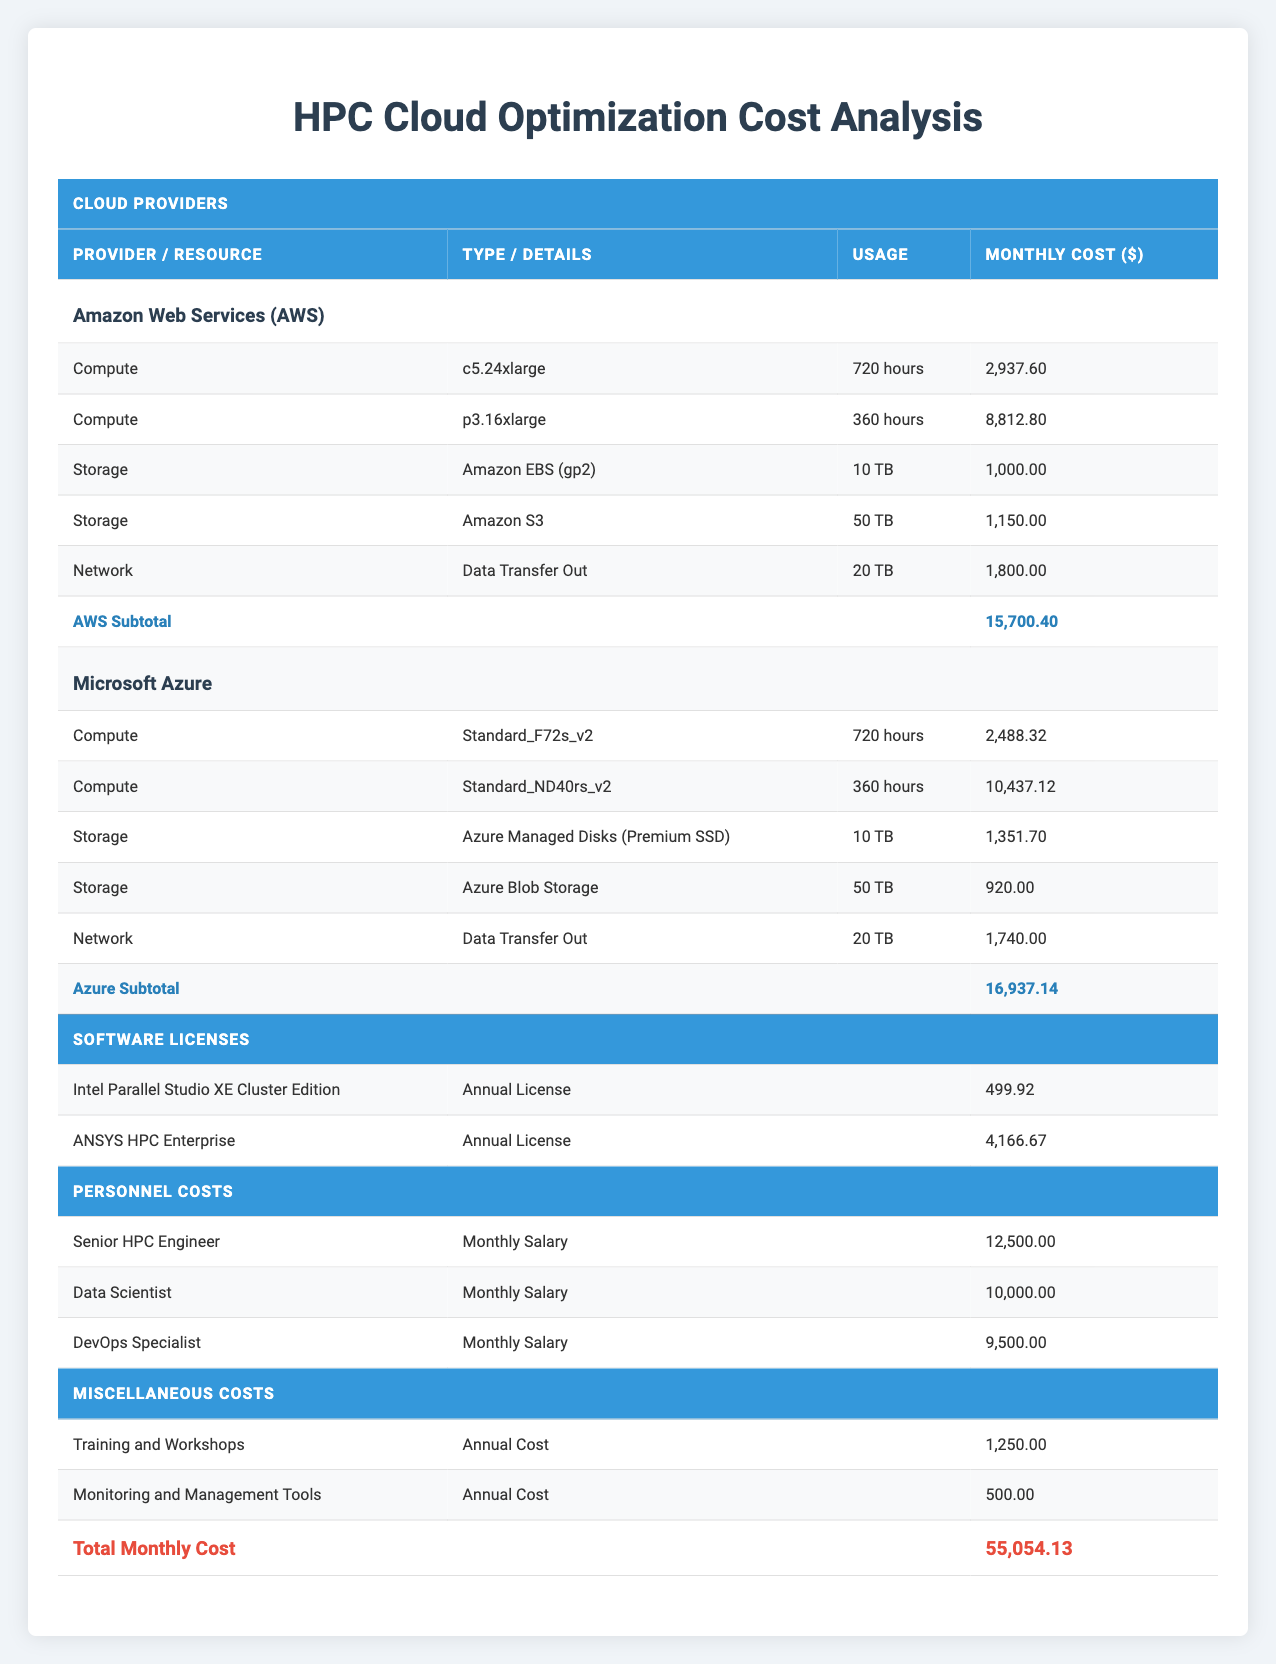What is the total monthly cost for using Amazon Web Services (AWS)? To find the total monthly cost for AWS, we need to sum up the monthly costs of its compute, storage, and network resources. The compute costs are 2,937.60 + 8,812.80 = 11,750.40. The storage costs are 1,000.00 + 1,150.00 = 2,150.00. The network cost is 1,800.00. Adding these together yields: 11,750.40 + 2,150.00 + 1,800.00 = 15,700.40.
Answer: 15,700.40 What is the monthly cost of the Standard_ND40rs_v2 instance on Microsoft Azure? The monthly cost for the Standard_ND40rs_v2 instance is clearly stated in the Azure section of the table as 10,437.12.
Answer: 10,437.12 Are the monthly costs of AWS storage resources higher than those of Microsoft Azure? The total monthly costs of AWS storage are 1,000.00 (EBS) + 1,150.00 (S3) = 2,150.00. The total monthly costs of Azure storage are 1,351.70 (Managed Disks) + 920.00 (Blob Storage) = 2,271.70. Comparing both totals shows that 2,150.00 (AWS) is not greater than 2,271.70 (Azure), therefore the statement is false.
Answer: No What is the difference in total monthly personnel costs between the Senior HPC Engineer and the Data Scientist? The monthly salary of the Senior HPC Engineer is 12,500.00, and the monthly salary of the Data Scientist is 10,000.00. To find the difference, we subtract the Data Scientist's salary from that of the Senior HPC Engineer: 12,500.00 - 10,000.00 = 2,500.00.
Answer: 2,500.00 Which cloud provider has the highest total monthly cost? First, we need to calculate the total costs for both AWS and Azure. For AWS, as calculated earlier, the total is 15,700.40, and for Azure, the total is 16,937.14 (adding the costs from compute, storage, and network). Comparing these totals shows that Azure has a higher total monthly cost than AWS, therefore Microsoft Azure is the provider with the highest costs.
Answer: Microsoft Azure What are the total costs of software licenses per month? The monthly cost for Intel Parallel Studio XE Cluster Edition is 499.92 and for ANSYS HPC Enterprise is 4,166.67. Adding these together gives a total software license cost of 499.92 + 4,166.67 = 4,666.59.
Answer: 4,666.59 What percentage of the total monthly cost is attributed to personnel costs? The personnel costs are the sum of the monthly salaries: 12,500.00 + 10,000.00 + 9,500.00 = 32,000.00. The total monthly cost is 55,054.13. To find the percentage, we use the formula: (32,000.00 / 55,054.13) * 100 = approximately 58.1%.
Answer: 58.1% Is the monthly cost of Amazon S3 less than the monthly cost for Azure Blob Storage? The monthly cost for Amazon S3 is 1,150.00, and for Azure Blob Storage, it is 920.00. Since 1,150.00 is greater than 920.00, the statement is false.
Answer: No What is the total cost for training and workshops over 12 months? The monthly cost for training and workshops is 1,250.00. Over 12 months, the total cost is calculated as 1,250.00 * 12 = 15,000.00.
Answer: 15,000.00 